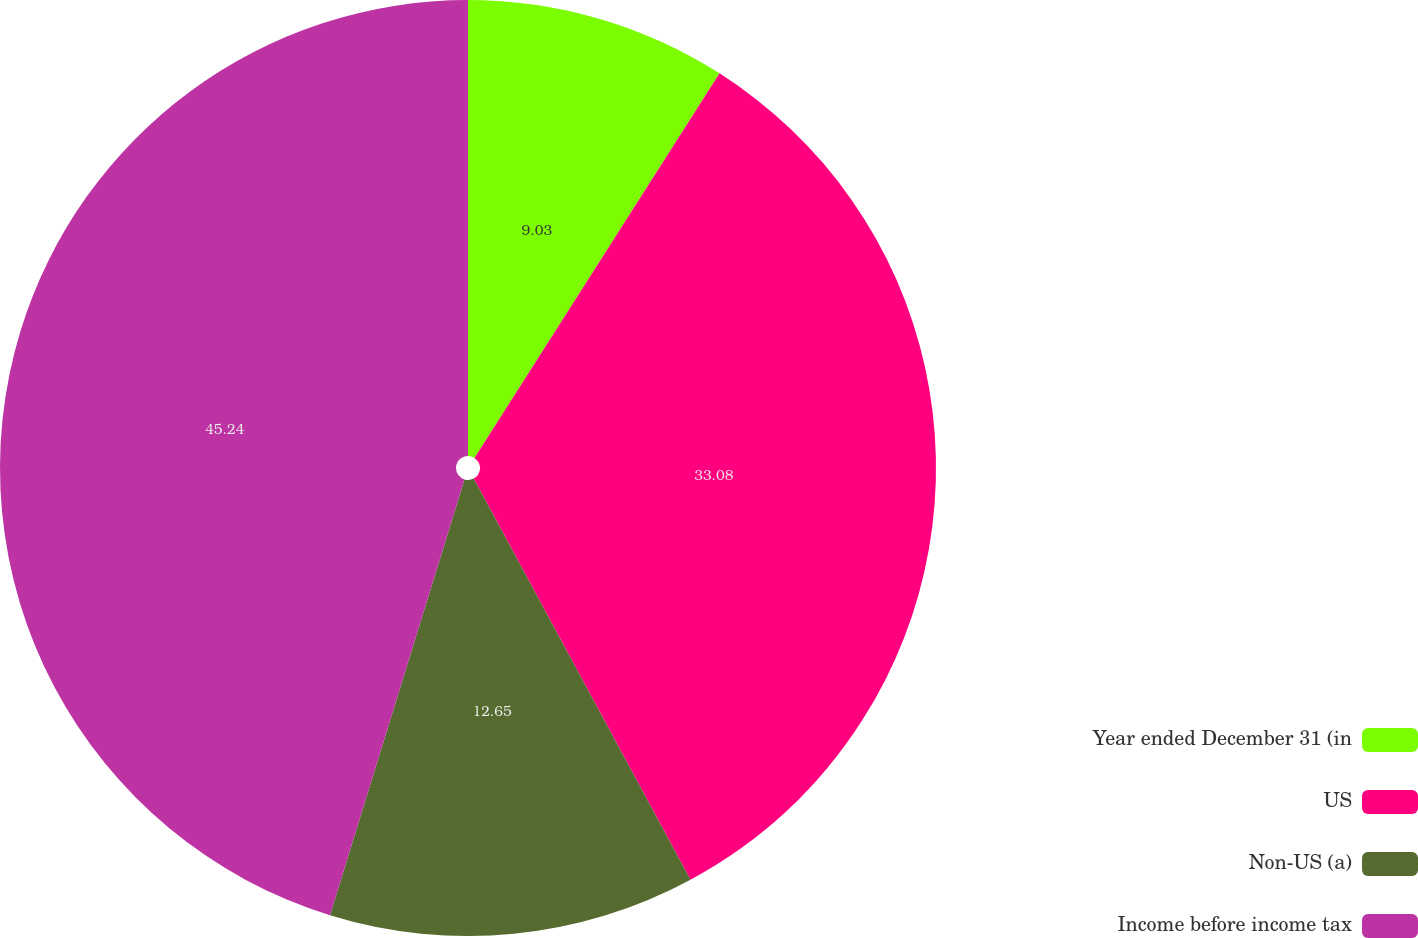Convert chart. <chart><loc_0><loc_0><loc_500><loc_500><pie_chart><fcel>Year ended December 31 (in<fcel>US<fcel>Non-US (a)<fcel>Income before income tax<nl><fcel>9.03%<fcel>33.08%<fcel>12.65%<fcel>45.23%<nl></chart> 